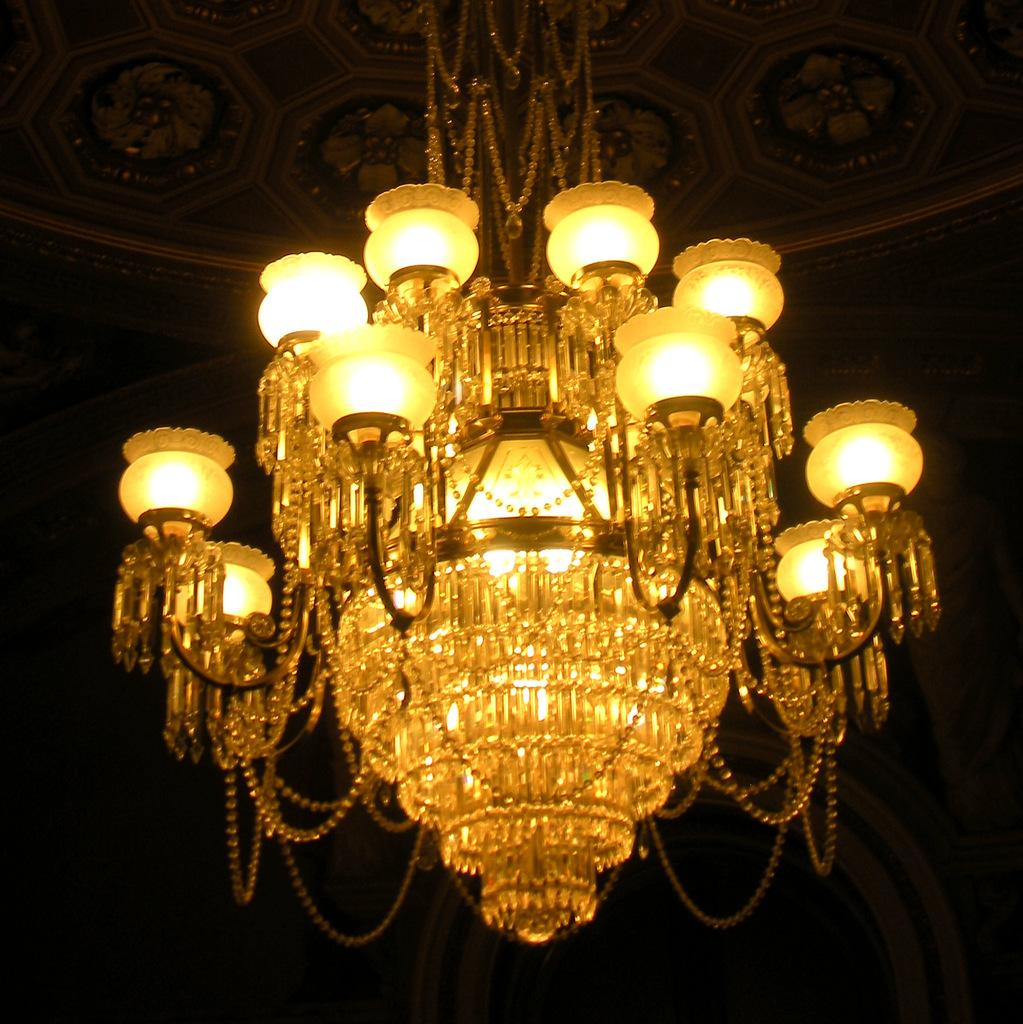What is the main object in the foreground of the image? There is a chandelier in the foreground of the image. How many holes can be seen in the chandelier in the image? There is no information about holes in the chandelier, so we cannot determine the number of holes from the image. 